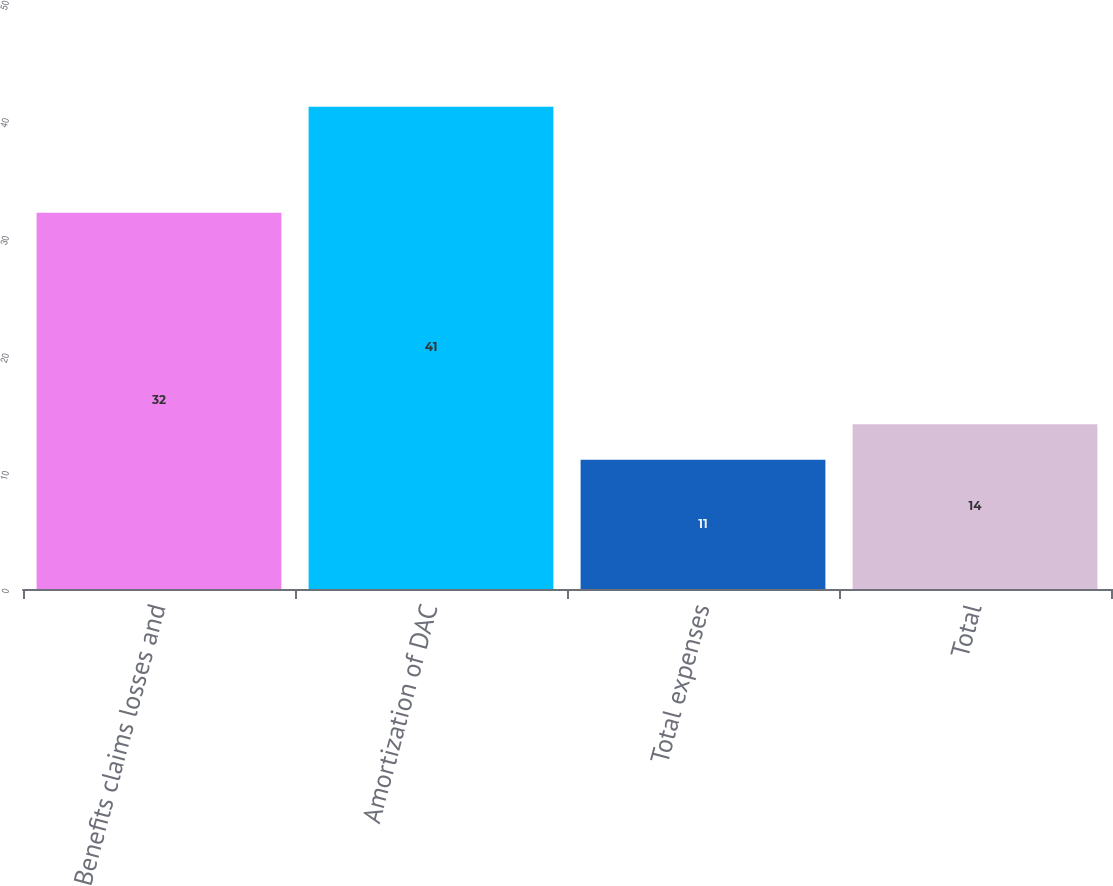<chart> <loc_0><loc_0><loc_500><loc_500><bar_chart><fcel>Benefits claims losses and<fcel>Amortization of DAC<fcel>Total expenses<fcel>Total<nl><fcel>32<fcel>41<fcel>11<fcel>14<nl></chart> 